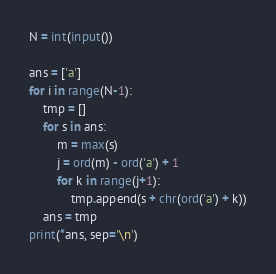Convert code to text. <code><loc_0><loc_0><loc_500><loc_500><_Python_>N = int(input())

ans = ['a']
for i in range(N-1):
    tmp = []
    for s in ans:
        m = max(s)
        j = ord(m) - ord('a') + 1
        for k in range(j+1):
            tmp.append(s + chr(ord('a') + k))
    ans = tmp
print(*ans, sep='\n')</code> 